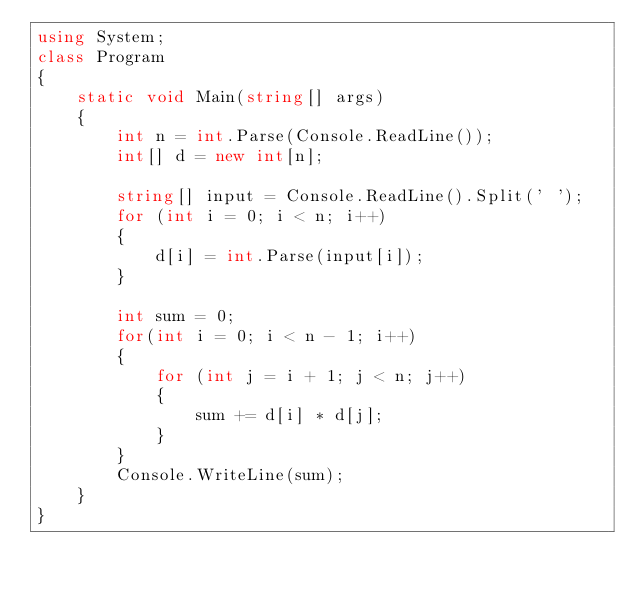Convert code to text. <code><loc_0><loc_0><loc_500><loc_500><_C#_>using System;
class Program
{
    static void Main(string[] args)
    {
        int n = int.Parse(Console.ReadLine());
        int[] d = new int[n];

        string[] input = Console.ReadLine().Split(' ');
        for (int i = 0; i < n; i++)
        {
            d[i] = int.Parse(input[i]);
        }

        int sum = 0;
        for(int i = 0; i < n - 1; i++)
        {
            for (int j = i + 1; j < n; j++)
            {
                sum += d[i] * d[j];
            }
        }
        Console.WriteLine(sum);
    }
}</code> 